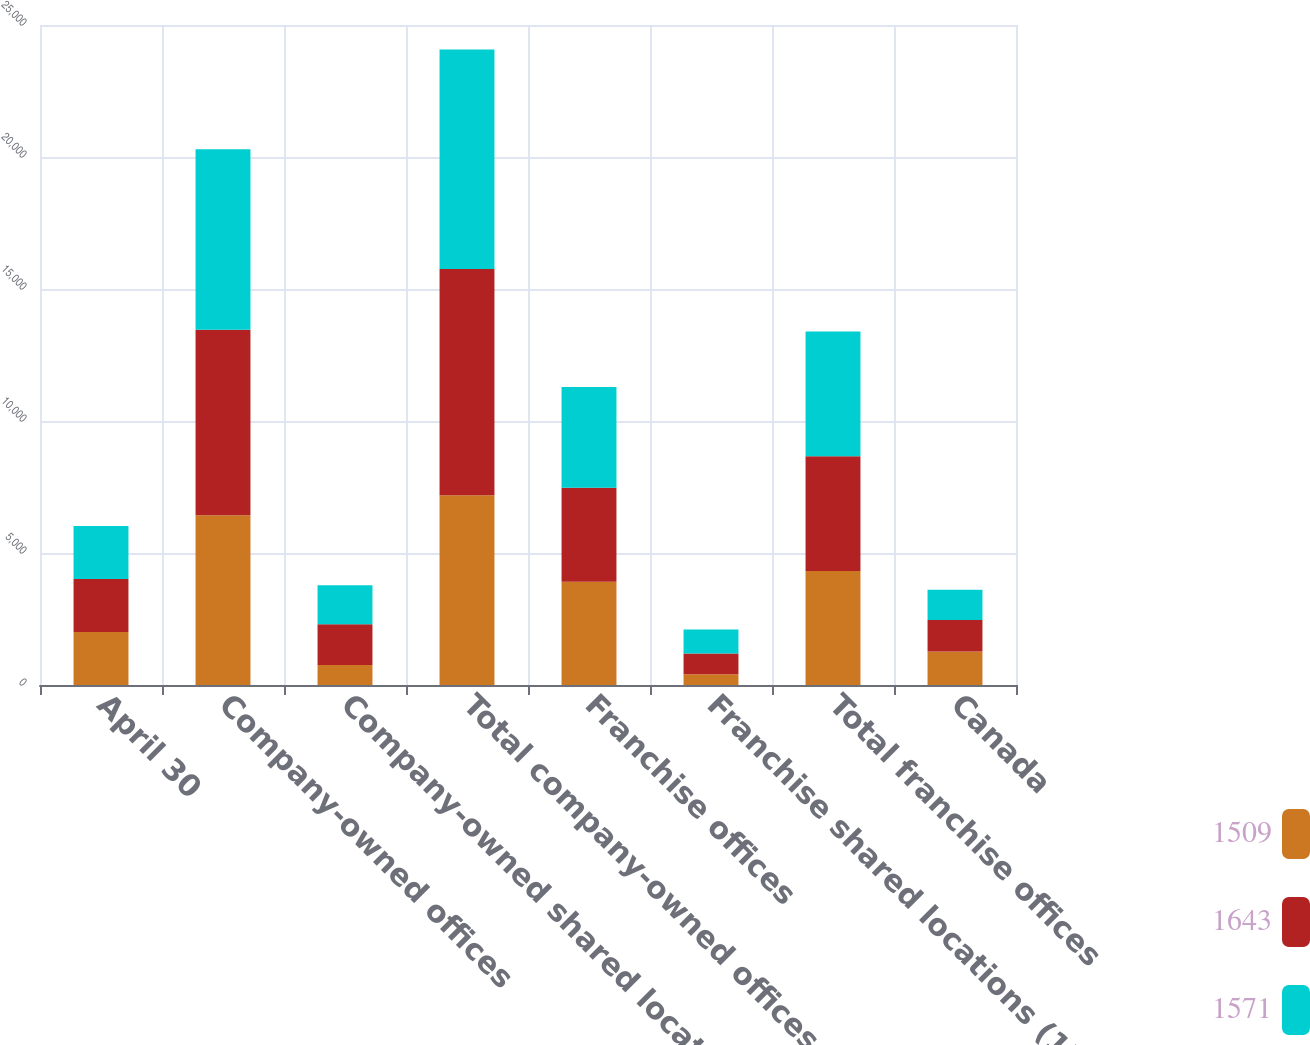Convert chart to OTSL. <chart><loc_0><loc_0><loc_500><loc_500><stacked_bar_chart><ecel><fcel>April 30<fcel>Company-owned offices<fcel>Company-owned shared locations<fcel>Total company-owned offices<fcel>Franchise offices<fcel>Franchise shared locations (1)<fcel>Total franchise offices<fcel>Canada<nl><fcel>1509<fcel>2010<fcel>6431<fcel>760<fcel>7191<fcel>3909<fcel>406<fcel>4315<fcel>1269<nl><fcel>1643<fcel>2009<fcel>7029<fcel>1542<fcel>8571<fcel>3565<fcel>787<fcel>4352<fcel>1193<nl><fcel>1571<fcel>2008<fcel>6835<fcel>1478<fcel>8313<fcel>3812<fcel>913<fcel>4725<fcel>1143<nl></chart> 